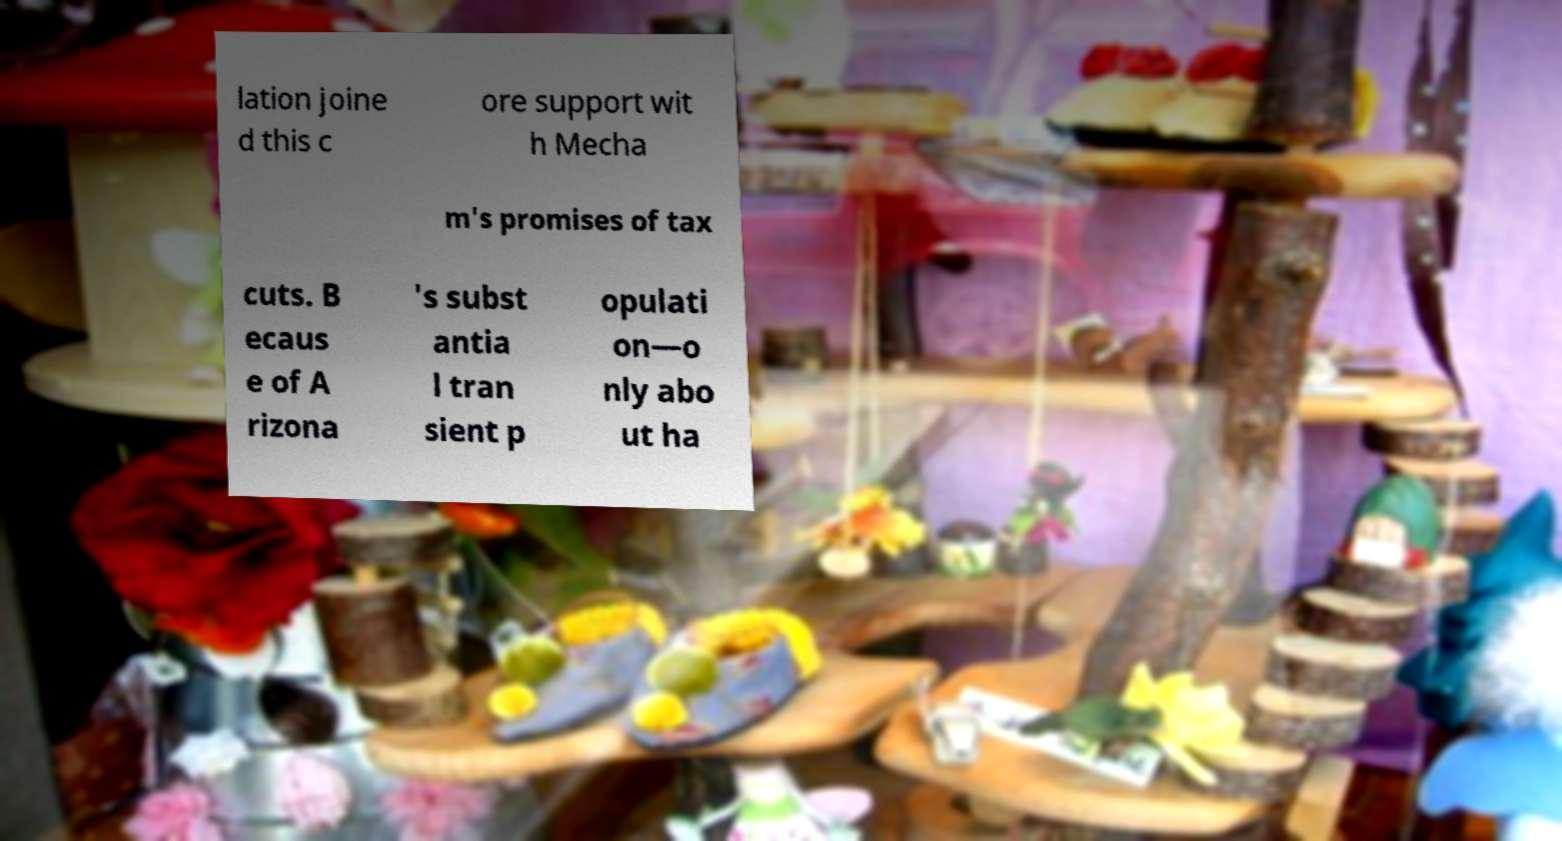Please read and relay the text visible in this image. What does it say? lation joine d this c ore support wit h Mecha m's promises of tax cuts. B ecaus e of A rizona 's subst antia l tran sient p opulati on—o nly abo ut ha 